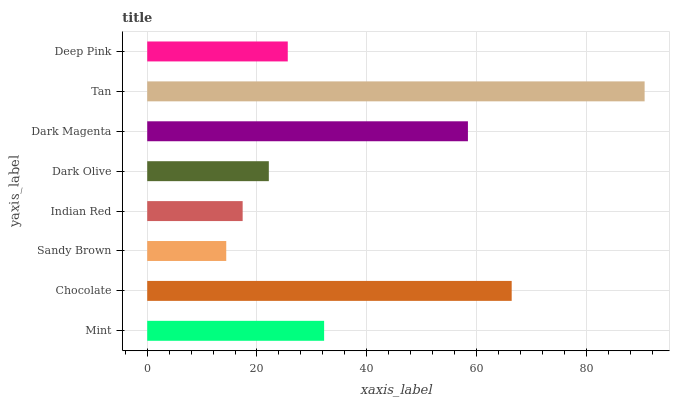Is Sandy Brown the minimum?
Answer yes or no. Yes. Is Tan the maximum?
Answer yes or no. Yes. Is Chocolate the minimum?
Answer yes or no. No. Is Chocolate the maximum?
Answer yes or no. No. Is Chocolate greater than Mint?
Answer yes or no. Yes. Is Mint less than Chocolate?
Answer yes or no. Yes. Is Mint greater than Chocolate?
Answer yes or no. No. Is Chocolate less than Mint?
Answer yes or no. No. Is Mint the high median?
Answer yes or no. Yes. Is Deep Pink the low median?
Answer yes or no. Yes. Is Sandy Brown the high median?
Answer yes or no. No. Is Mint the low median?
Answer yes or no. No. 